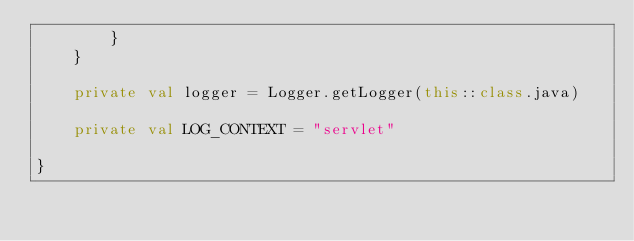Convert code to text. <code><loc_0><loc_0><loc_500><loc_500><_Kotlin_>        }
    }

    private val logger = Logger.getLogger(this::class.java)

    private val LOG_CONTEXT = "servlet"

}
</code> 